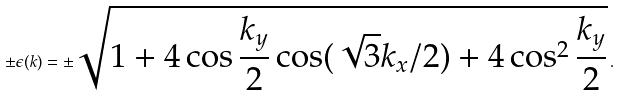<formula> <loc_0><loc_0><loc_500><loc_500>\pm \epsilon ( { k } ) = \pm \sqrt { 1 + 4 \cos \frac { k _ { y } } { 2 } \cos ( \sqrt { 3 } k _ { x } / 2 ) + 4 \cos ^ { 2 } \frac { k _ { y } } { 2 } } \, .</formula> 